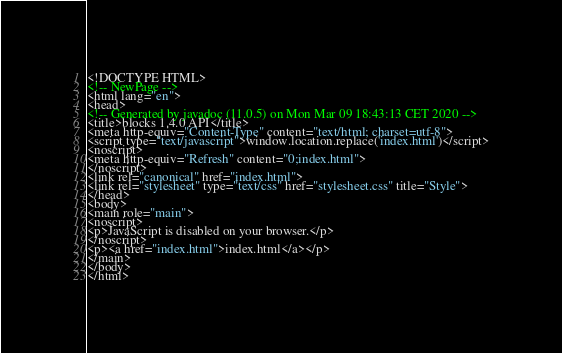Convert code to text. <code><loc_0><loc_0><loc_500><loc_500><_HTML_><!DOCTYPE HTML>
<!-- NewPage -->
<html lang="en">
<head>
<!-- Generated by javadoc (11.0.5) on Mon Mar 09 18:43:13 CET 2020 -->
<title>blocks 1.4.0 API</title>
<meta http-equiv="Content-Type" content="text/html; charset=utf-8">
<script type="text/javascript">window.location.replace('index.html')</script>
<noscript>
<meta http-equiv="Refresh" content="0;index.html">
</noscript>
<link rel="canonical" href="index.html">
<link rel="stylesheet" type="text/css" href="stylesheet.css" title="Style">
</head>
<body>
<main role="main">
<noscript>
<p>JavaScript is disabled on your browser.</p>
</noscript>
<p><a href="index.html">index.html</a></p>
</main>
</body>
</html>
</code> 